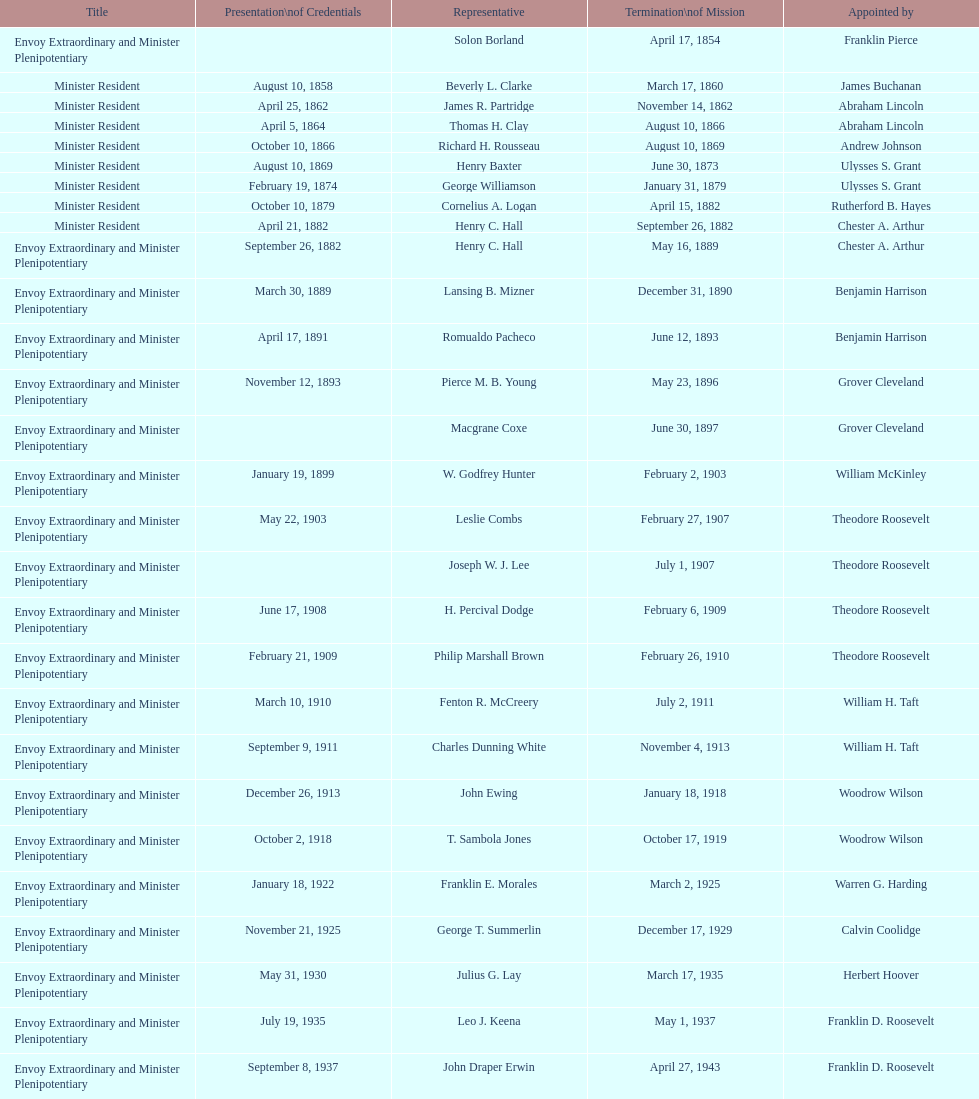What was the length, in years, of leslie combs' term? 4 years. 